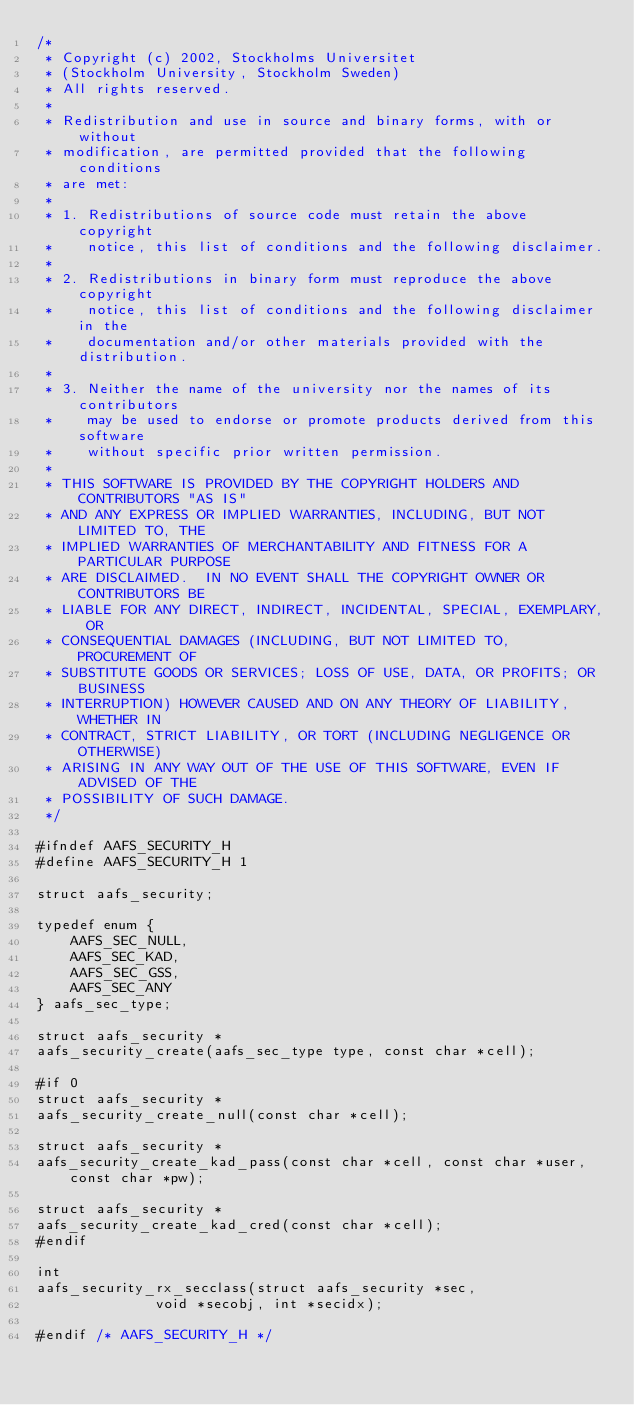<code> <loc_0><loc_0><loc_500><loc_500><_C_>/*
 * Copyright (c) 2002, Stockholms Universitet
 * (Stockholm University, Stockholm Sweden)
 * All rights reserved.
 *
 * Redistribution and use in source and binary forms, with or without
 * modification, are permitted provided that the following conditions
 * are met:
 *
 * 1. Redistributions of source code must retain the above copyright
 *    notice, this list of conditions and the following disclaimer.
 *
 * 2. Redistributions in binary form must reproduce the above copyright
 *    notice, this list of conditions and the following disclaimer in the
 *    documentation and/or other materials provided with the distribution.
 *
 * 3. Neither the name of the university nor the names of its contributors
 *    may be used to endorse or promote products derived from this software
 *    without specific prior written permission.
 *
 * THIS SOFTWARE IS PROVIDED BY THE COPYRIGHT HOLDERS AND CONTRIBUTORS "AS IS"
 * AND ANY EXPRESS OR IMPLIED WARRANTIES, INCLUDING, BUT NOT LIMITED TO, THE
 * IMPLIED WARRANTIES OF MERCHANTABILITY AND FITNESS FOR A PARTICULAR PURPOSE
 * ARE DISCLAIMED.  IN NO EVENT SHALL THE COPYRIGHT OWNER OR CONTRIBUTORS BE
 * LIABLE FOR ANY DIRECT, INDIRECT, INCIDENTAL, SPECIAL, EXEMPLARY, OR
 * CONSEQUENTIAL DAMAGES (INCLUDING, BUT NOT LIMITED TO, PROCUREMENT OF
 * SUBSTITUTE GOODS OR SERVICES; LOSS OF USE, DATA, OR PROFITS; OR BUSINESS
 * INTERRUPTION) HOWEVER CAUSED AND ON ANY THEORY OF LIABILITY, WHETHER IN
 * CONTRACT, STRICT LIABILITY, OR TORT (INCLUDING NEGLIGENCE OR OTHERWISE)
 * ARISING IN ANY WAY OUT OF THE USE OF THIS SOFTWARE, EVEN IF ADVISED OF THE
 * POSSIBILITY OF SUCH DAMAGE.
 */

#ifndef AAFS_SECURITY_H
#define AAFS_SECURITY_H 1

struct aafs_security;

typedef enum {
	AAFS_SEC_NULL,
	AAFS_SEC_KAD,
	AAFS_SEC_GSS,
	AAFS_SEC_ANY
} aafs_sec_type;

struct aafs_security *
aafs_security_create(aafs_sec_type type, const char *cell);

#if 0
struct aafs_security *
aafs_security_create_null(const char *cell);

struct aafs_security *
aafs_security_create_kad_pass(const char *cell, const char *user, const char *pw);

struct aafs_security *
aafs_security_create_kad_cred(const char *cell);
#endif

int
aafs_security_rx_secclass(struct aafs_security *sec,
			  void *secobj, int *secidx);

#endif /* AAFS_SECURITY_H */
</code> 